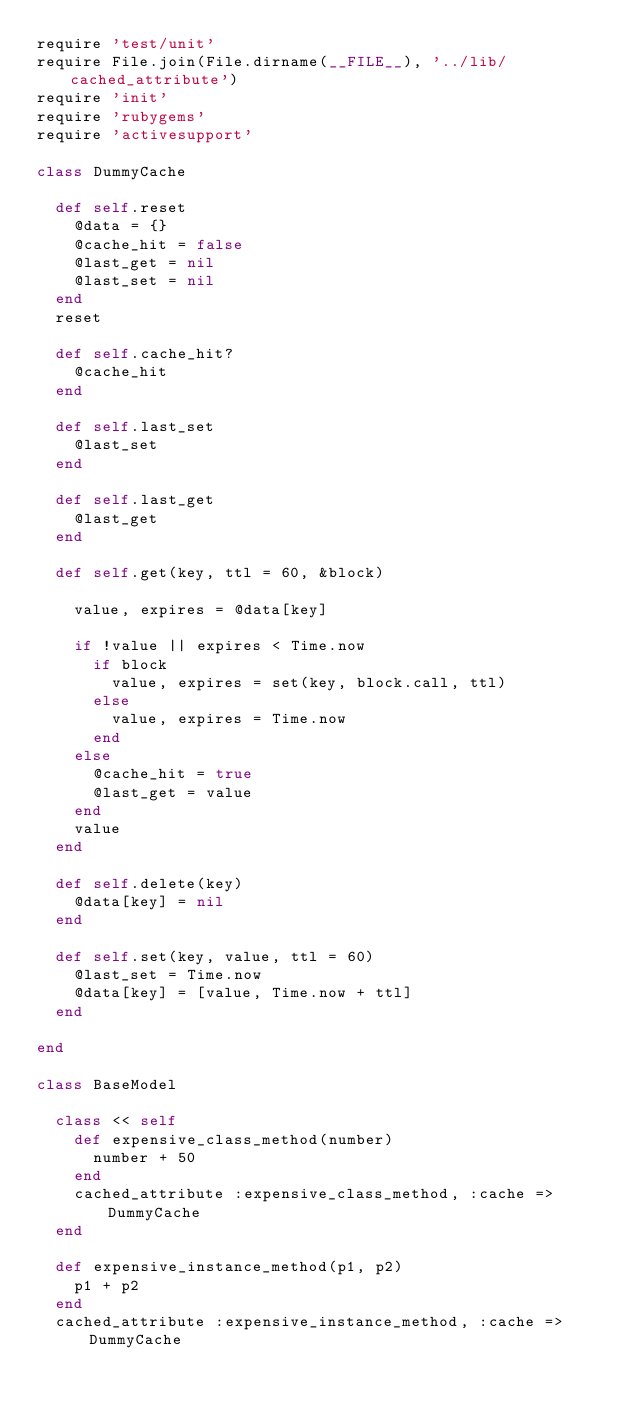<code> <loc_0><loc_0><loc_500><loc_500><_Ruby_>require 'test/unit'
require File.join(File.dirname(__FILE__), '../lib/cached_attribute')
require 'init'
require 'rubygems'
require 'activesupport'

class DummyCache

  def self.reset
    @data = {}
    @cache_hit = false
    @last_get = nil
    @last_set = nil
  end
  reset

  def self.cache_hit?
    @cache_hit
  end
  
  def self.last_set
    @last_set
  end

  def self.last_get
    @last_get
  end
  
  def self.get(key, ttl = 60, &block)
    
    value, expires = @data[key]

    if !value || expires < Time.now
      if block
        value, expires = set(key, block.call, ttl)
      else
        value, expires = Time.now
      end
    else
      @cache_hit = true
      @last_get = value
    end
    value
  end

  def self.delete(key)
    @data[key] = nil
  end

  def self.set(key, value, ttl = 60)
    @last_set = Time.now
    @data[key] = [value, Time.now + ttl]
  end

end

class BaseModel

  class << self
    def expensive_class_method(number)
      number + 50
    end
    cached_attribute :expensive_class_method, :cache => DummyCache
  end

  def expensive_instance_method(p1, p2)
    p1 + p2
  end
  cached_attribute :expensive_instance_method, :cache => DummyCache
</code> 